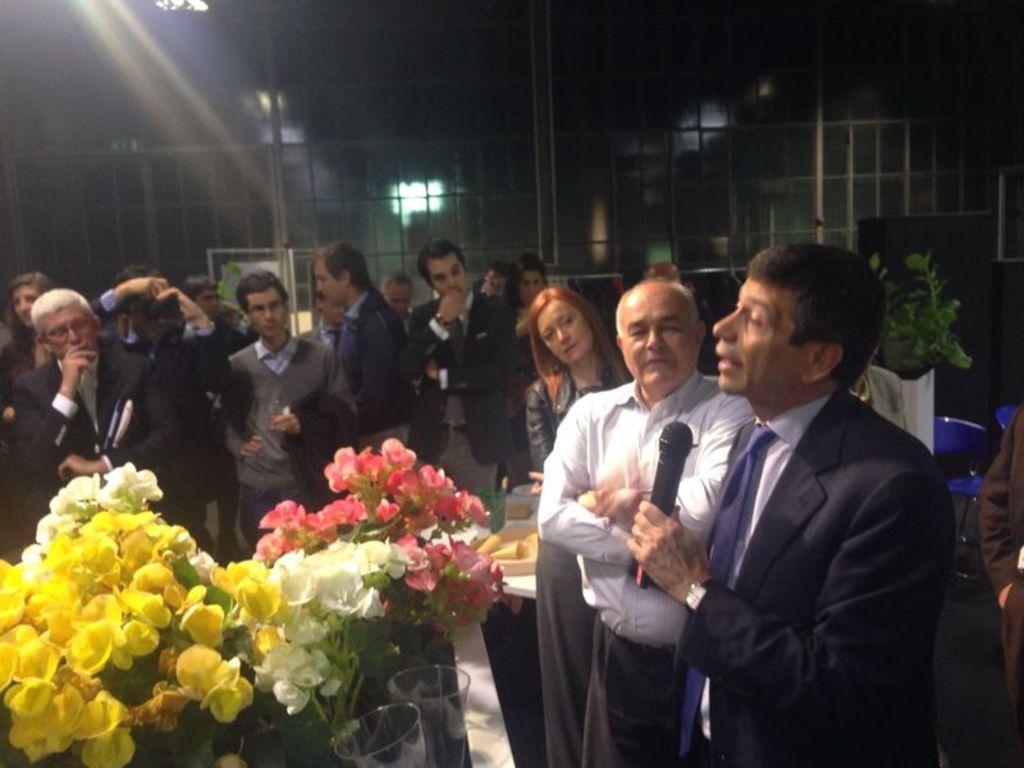Please provide a concise description of this image. In this image I can see few people are standing and wearing different color dresses. In front I can see few flowers in pink, yellow, white color and one person is holding a mic. Background is dark. 